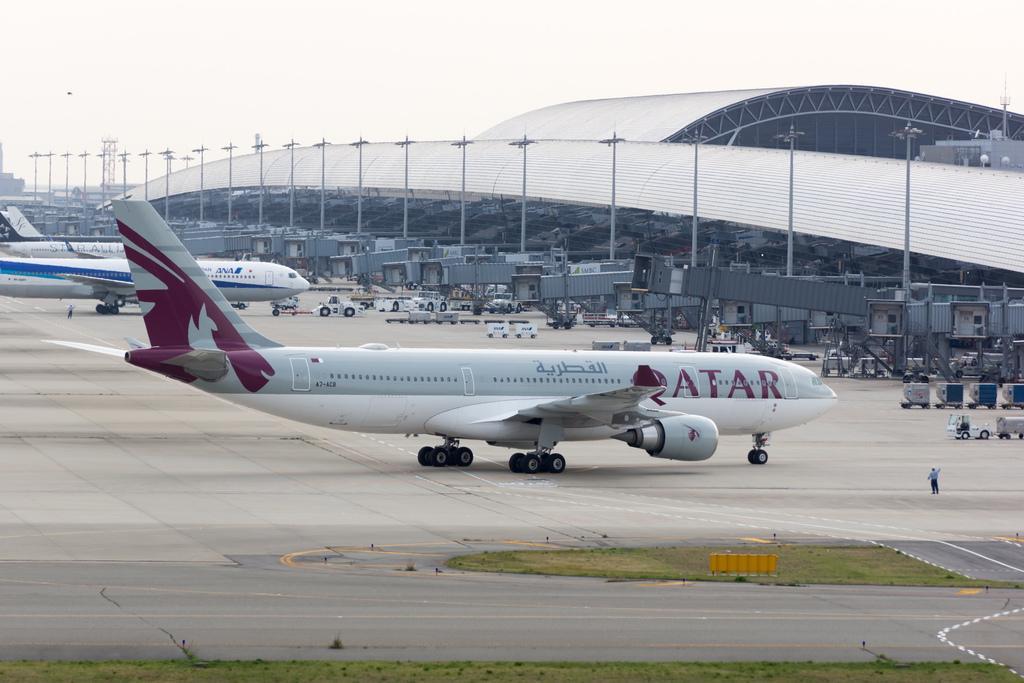Could you give a brief overview of what you see in this image? In this image there is one Aeroplane in middle of this image which is in white color. There are some other Aeroplanes at left side of this image and there are some trucks which is in white color in middle of this image. There is a building at right side of this image and there are some moles as we can see in middle of this image. There is one person standing at bottom right side of this image and there is a ground as we can see at left side of this image. there is a sky at top of this image. 